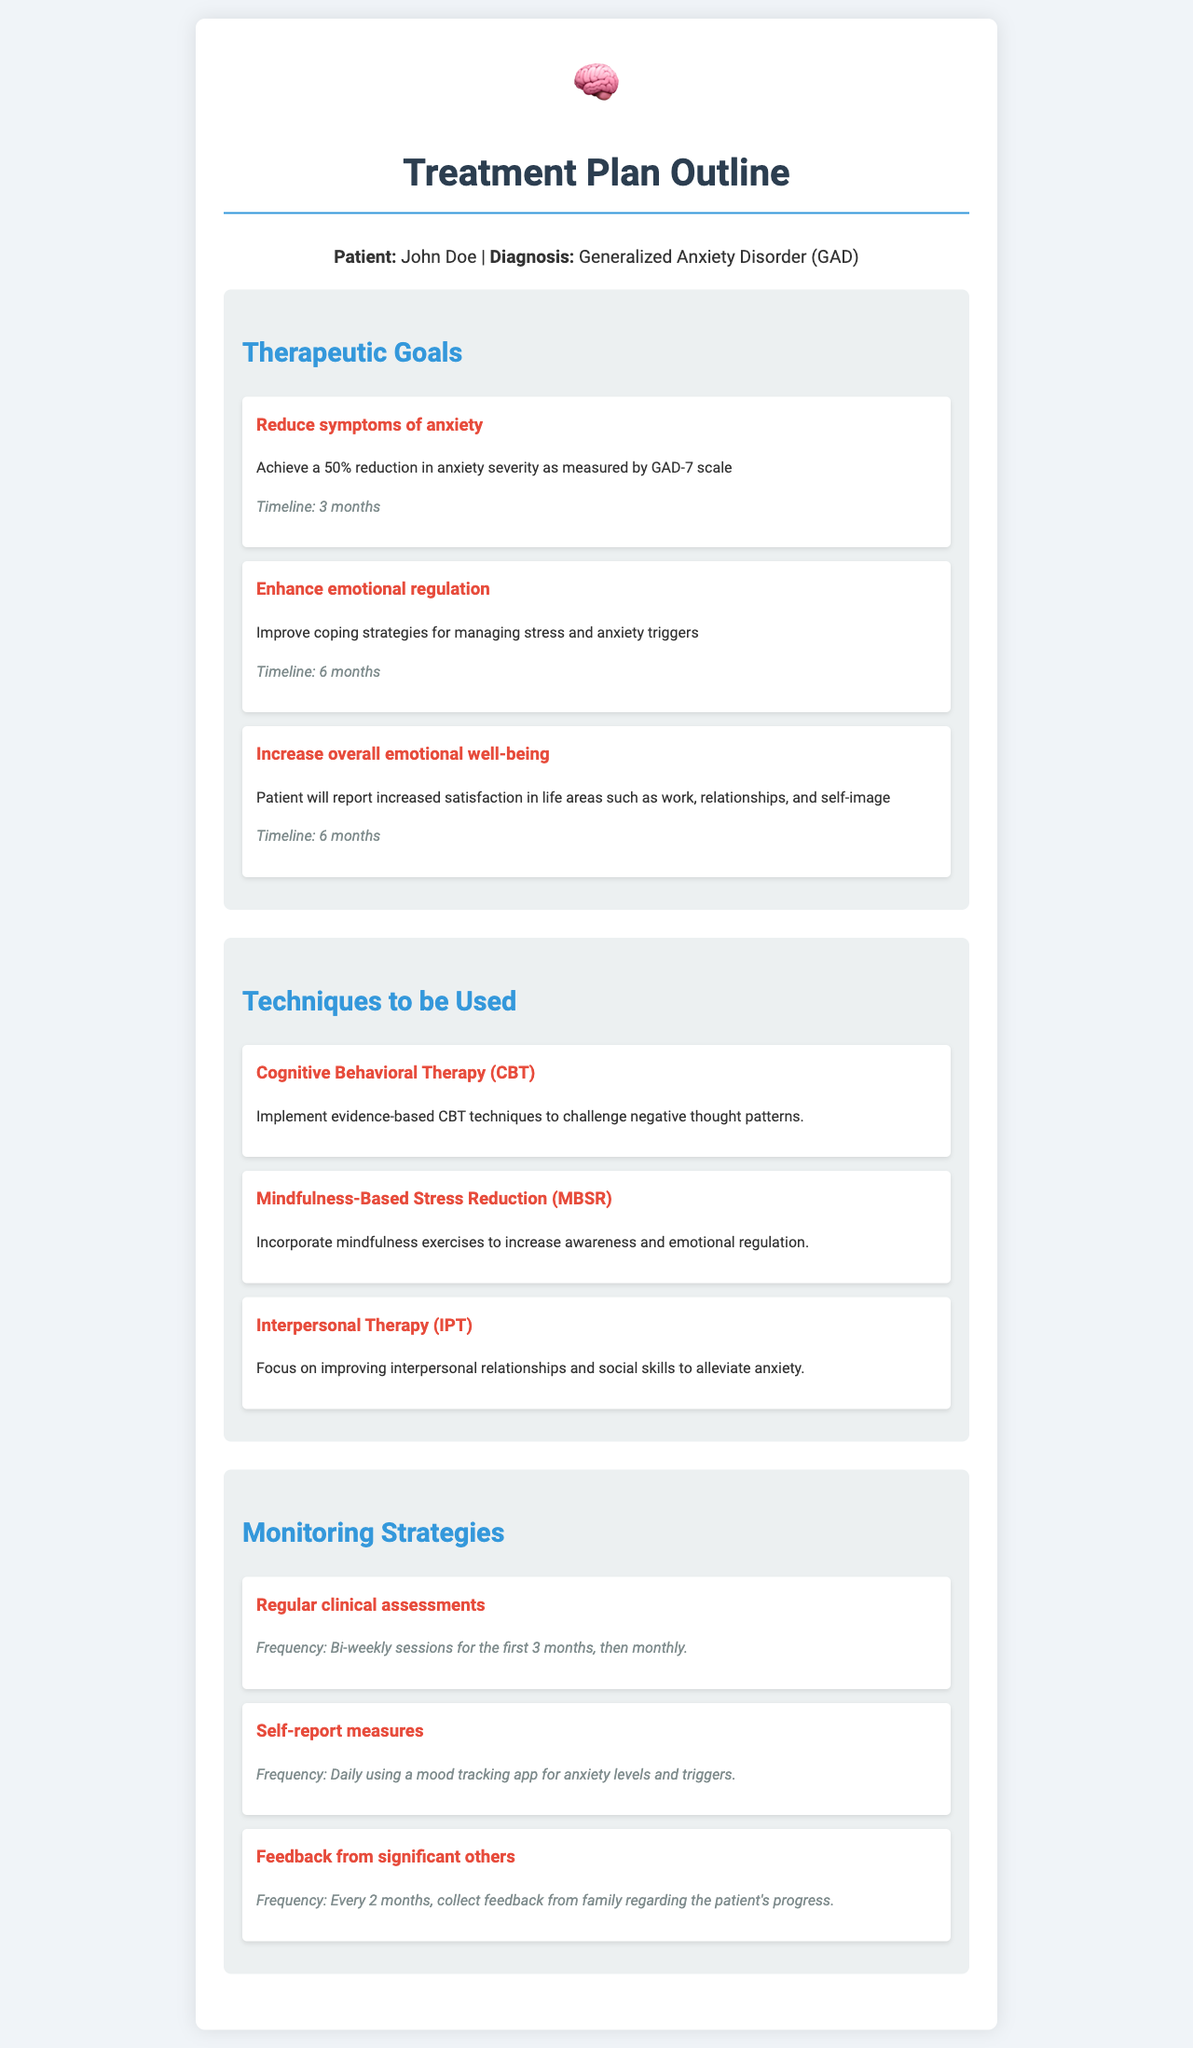What is the patient's name? The patient's name is stated at the beginning of the document under the patient information section.
Answer: John Doe What is the diagnosis? The diagnosis is listed alongside the patient's name in the document.
Answer: Generalized Anxiety Disorder (GAD) What is the timeline for reducing symptoms of anxiety? The timeline is specified under the therapeutic goals section related to reducing anxiety severity.
Answer: 3 months What technique involves implementing evidence-based methods? This refers to the therapeutic techniques section discussing the techniques used in the treatment plan.
Answer: Cognitive Behavioral Therapy (CBT) What is the frequency of regular clinical assessments? This frequency is detailed in the monitoring strategies section related to clinical assessments.
Answer: Bi-weekly sessions for the first 3 months, then monthly How much reduction in anxiety severity is aimed for? This is specified in the goals pertaining to reducing symptoms of anxiety.
Answer: 50% What is one goal regarding emotional well-being? This goal can be found in the therapeutic goals section outlining improvement in life satisfaction.
Answer: Increase satisfaction in life areas such as work, relationships, and self-image What therapy focuses on interpersonal relationships? This detail is captured in the techniques section detailing various therapeutic approaches.
Answer: Interpersonal Therapy (IPT) What is the frequency for feedback from significant others? This is specified under the monitoring strategies regarding gathering feedback for patient progress.
Answer: Every 2 months 